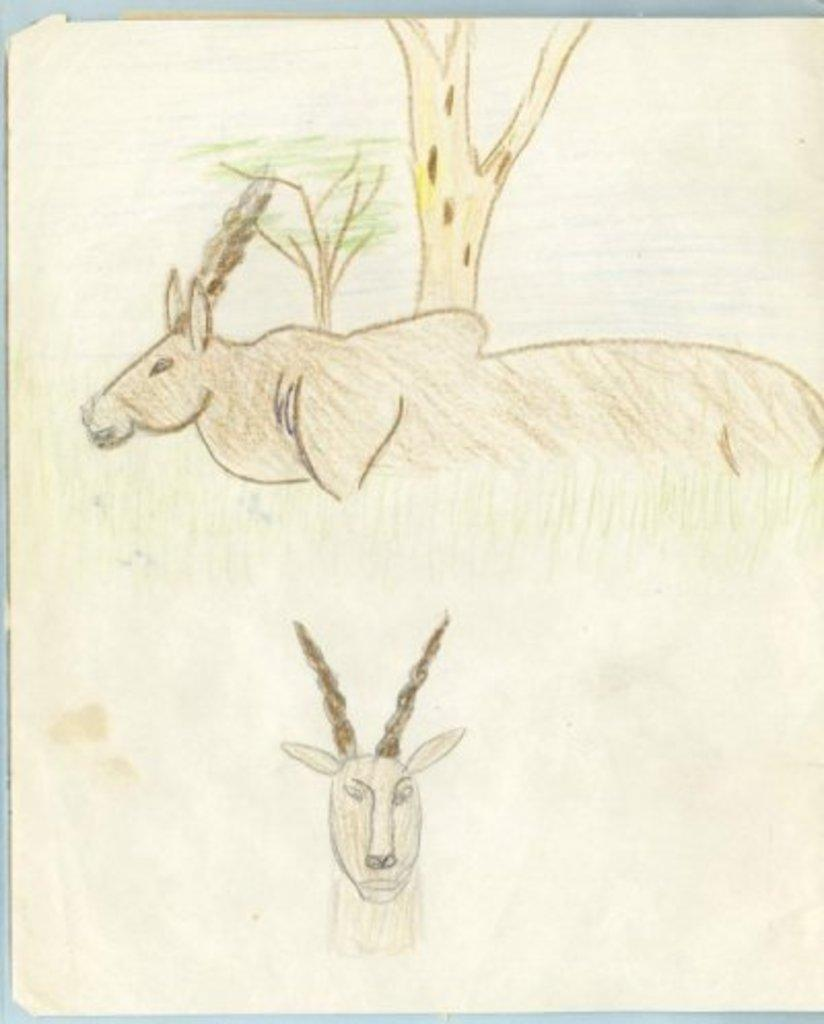What is depicted in the image? There is a drawing of two animals in the image. What can be seen in the background of the drawing? There are trees in the background of the image. What design does the son use to create the drawing in the image? There is no information about the son or the design used to create the drawing in the image. 